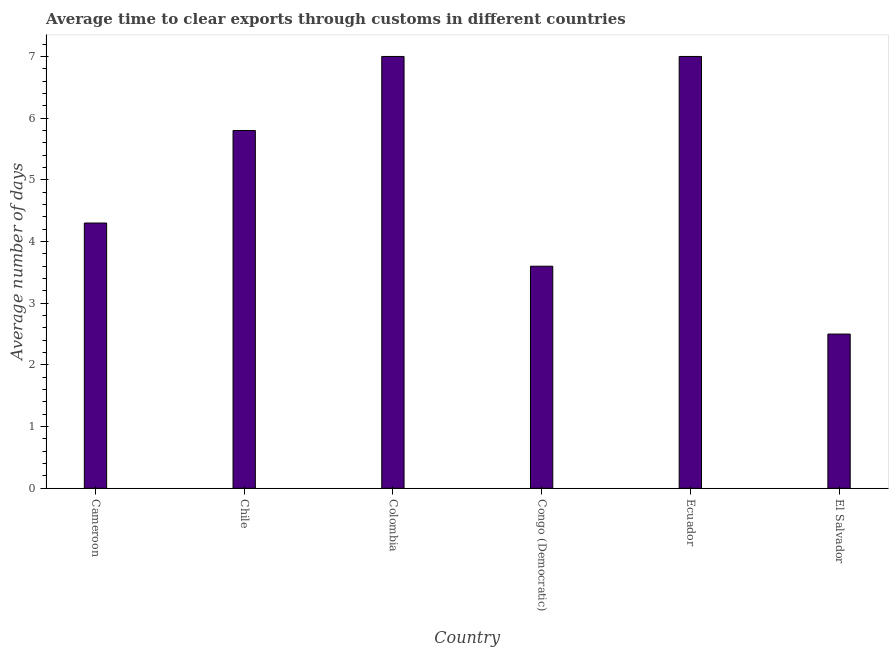Does the graph contain any zero values?
Make the answer very short. No. Does the graph contain grids?
Ensure brevity in your answer.  No. What is the title of the graph?
Your answer should be compact. Average time to clear exports through customs in different countries. What is the label or title of the Y-axis?
Provide a succinct answer. Average number of days. Across all countries, what is the maximum time to clear exports through customs?
Your response must be concise. 7. In which country was the time to clear exports through customs minimum?
Give a very brief answer. El Salvador. What is the sum of the time to clear exports through customs?
Your answer should be compact. 30.2. What is the average time to clear exports through customs per country?
Your answer should be very brief. 5.03. What is the median time to clear exports through customs?
Keep it short and to the point. 5.05. What is the ratio of the time to clear exports through customs in Congo (Democratic) to that in El Salvador?
Your answer should be compact. 1.44. Is the time to clear exports through customs in Cameroon less than that in Ecuador?
Ensure brevity in your answer.  Yes. What is the difference between the highest and the second highest time to clear exports through customs?
Make the answer very short. 0. What is the difference between two consecutive major ticks on the Y-axis?
Ensure brevity in your answer.  1. What is the Average number of days of Chile?
Give a very brief answer. 5.8. What is the Average number of days of Colombia?
Provide a succinct answer. 7. What is the Average number of days in Congo (Democratic)?
Provide a succinct answer. 3.6. What is the Average number of days of Ecuador?
Provide a short and direct response. 7. What is the difference between the Average number of days in Cameroon and Chile?
Keep it short and to the point. -1.5. What is the difference between the Average number of days in Cameroon and Colombia?
Your response must be concise. -2.7. What is the difference between the Average number of days in Cameroon and Ecuador?
Provide a short and direct response. -2.7. What is the difference between the Average number of days in Cameroon and El Salvador?
Offer a very short reply. 1.8. What is the difference between the Average number of days in Chile and Colombia?
Give a very brief answer. -1.2. What is the difference between the Average number of days in Chile and El Salvador?
Provide a short and direct response. 3.3. What is the difference between the Average number of days in Colombia and Congo (Democratic)?
Offer a terse response. 3.4. What is the difference between the Average number of days in Colombia and Ecuador?
Offer a very short reply. 0. What is the ratio of the Average number of days in Cameroon to that in Chile?
Your answer should be compact. 0.74. What is the ratio of the Average number of days in Cameroon to that in Colombia?
Ensure brevity in your answer.  0.61. What is the ratio of the Average number of days in Cameroon to that in Congo (Democratic)?
Keep it short and to the point. 1.19. What is the ratio of the Average number of days in Cameroon to that in Ecuador?
Offer a very short reply. 0.61. What is the ratio of the Average number of days in Cameroon to that in El Salvador?
Offer a terse response. 1.72. What is the ratio of the Average number of days in Chile to that in Colombia?
Offer a very short reply. 0.83. What is the ratio of the Average number of days in Chile to that in Congo (Democratic)?
Give a very brief answer. 1.61. What is the ratio of the Average number of days in Chile to that in Ecuador?
Offer a very short reply. 0.83. What is the ratio of the Average number of days in Chile to that in El Salvador?
Offer a very short reply. 2.32. What is the ratio of the Average number of days in Colombia to that in Congo (Democratic)?
Make the answer very short. 1.94. What is the ratio of the Average number of days in Colombia to that in Ecuador?
Keep it short and to the point. 1. What is the ratio of the Average number of days in Congo (Democratic) to that in Ecuador?
Your answer should be very brief. 0.51. What is the ratio of the Average number of days in Congo (Democratic) to that in El Salvador?
Your answer should be compact. 1.44. What is the ratio of the Average number of days in Ecuador to that in El Salvador?
Give a very brief answer. 2.8. 